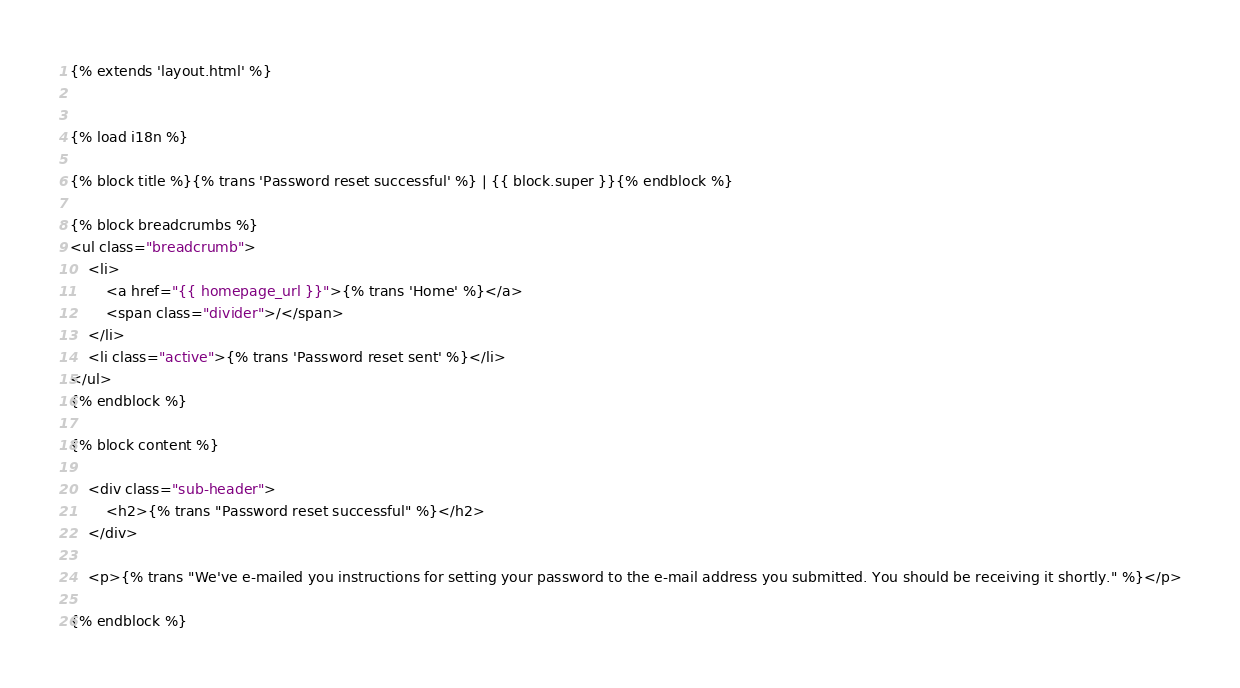Convert code to text. <code><loc_0><loc_0><loc_500><loc_500><_HTML_>{% extends 'layout.html' %}


{% load i18n %}

{% block title %}{% trans 'Password reset successful' %} | {{ block.super }}{% endblock %}

{% block breadcrumbs %}
<ul class="breadcrumb">
    <li>
        <a href="{{ homepage_url }}">{% trans 'Home' %}</a>
        <span class="divider">/</span>
    </li>
    <li class="active">{% trans 'Password reset sent' %}</li>
</ul>
{% endblock %}

{% block content %}

    <div class="sub-header">
        <h2>{% trans "Password reset successful" %}</h2>
    </div>

    <p>{% trans "We've e-mailed you instructions for setting your password to the e-mail address you submitted. You should be receiving it shortly." %}</p>

{% endblock %}
</code> 